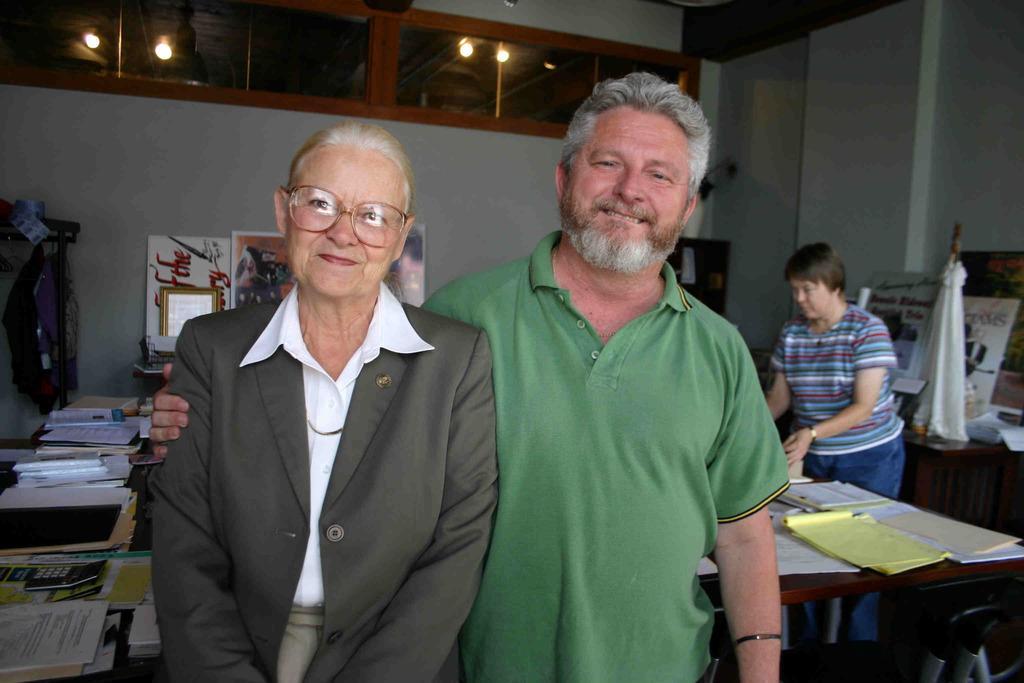Please provide a concise description of this image. In this image i can see a woman and a man standing at the back ground i can see a woman standing, few papers on table, a board, a tree, a glass , a light. 